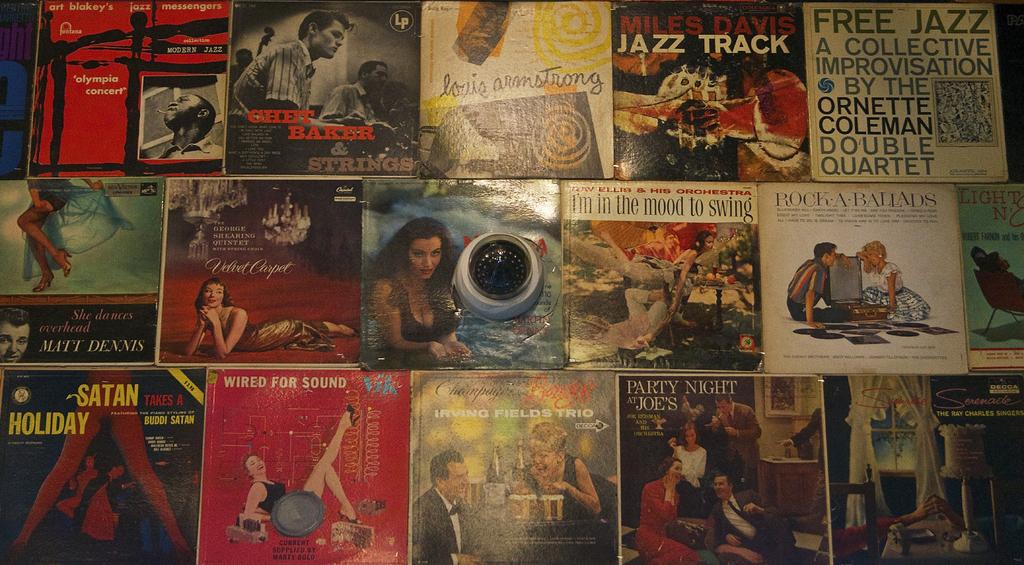Provide a one-sentence caption for the provided image. A group of posters, one of which contains the text FREE JAZZ. 